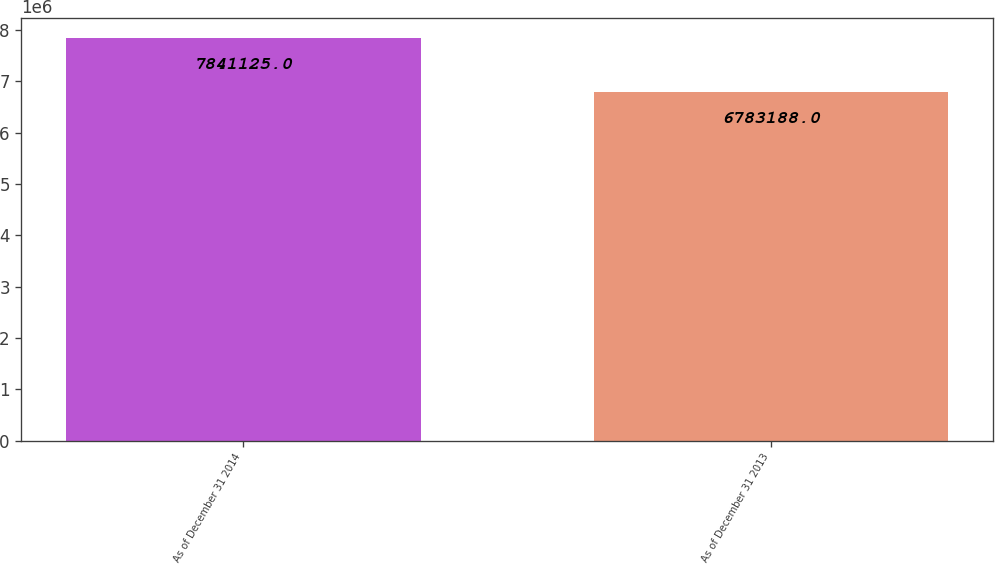<chart> <loc_0><loc_0><loc_500><loc_500><bar_chart><fcel>As of December 31 2014<fcel>As of December 31 2013<nl><fcel>7.84112e+06<fcel>6.78319e+06<nl></chart> 